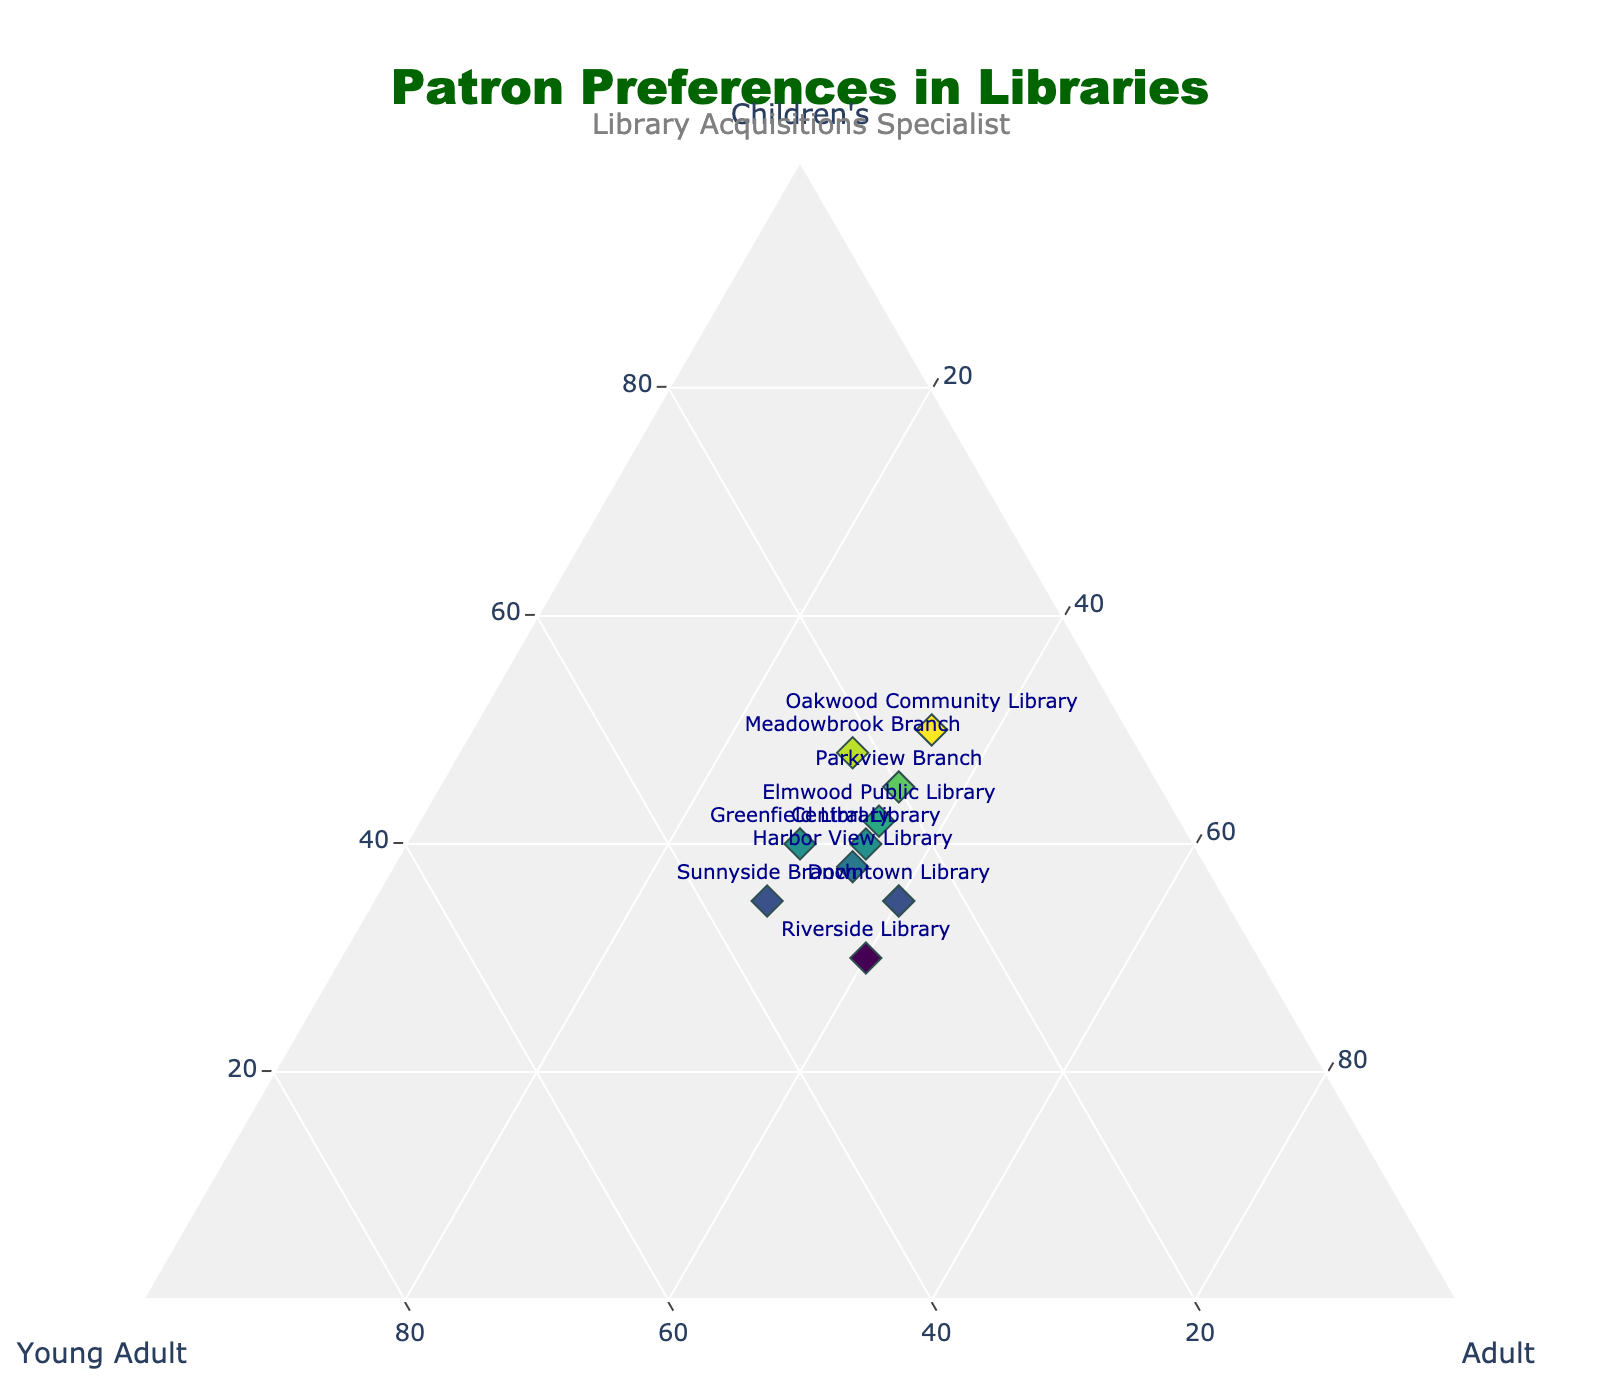What's the title of the figure? The figure's title is usually prominently displayed at the top center of the plot. It indicates what the chart is about.
Answer: Patron Preferences in Libraries How many libraries are represented in the figure? The figure includes different markers, each associated with a library name. By counting the total number of unique markers or library names, you can determine the number of libraries represented.
Answer: 10 Which library shows the highest preference for children's literature? By looking at the ternary plot and identifying the marker that is closest to the "Children's" axis (one of the corners of the plot) with the highest value, we can determine the library with the highest preference for children's literature.
Answer: Oakwood Community Library What is the color scheme used for the markers? The marker color is mapped to the value of children's literature preferences. By examining the plot and the color gradient, one can identify the colors used.
Answer: Viridis Which two libraries show equal preferences for adult literature? By looking for markers that have equal distances along the "Adult" axis, where 'Adult' percentages match, one can identify the libraries with equal preferences for adult literature.
Answer: Central Library and Parkview Branch What's the average preference for Young Adult literature across all libraries? First, add up the percentages for Young Adult literature from all libraries. Then, divide by the number of libraries to get the average. (25 + 20 + 30 + 15 + 35 + 23 + 27 + 22 + 25 + 30) / 10 = 25.2.
Answer: 25.2 Which library shows a balanced preference among the three literature categories? A balanced preference would place a library's marker near the center of the ternary plot. Look for the marker roughly equidistant from all three axes.
Answer: Sunnyside Branch Is there a library with 50% or more preference in any single literature category, and if so, which one? By examining the plot and checking each library's values, you can determine if any library has a preference of 50% or higher in one category.
Answer: Oakwood Community Library (Children's) Which library has the lowest preference for Young Adult literature? By identifying the marker that is closest to the opposite side of the "Young Adult" axis, you can find the library with the lowest preference for Young Adult literature.
Answer: Oakwood Community Library Which two libraries have the closest overall distribution of preferences? By visually identifying markers that are positioned closest to each other on the ternary plot, you can determine which libraries have similar preference distributions.
Answer: Central Library and Harbor View Library 